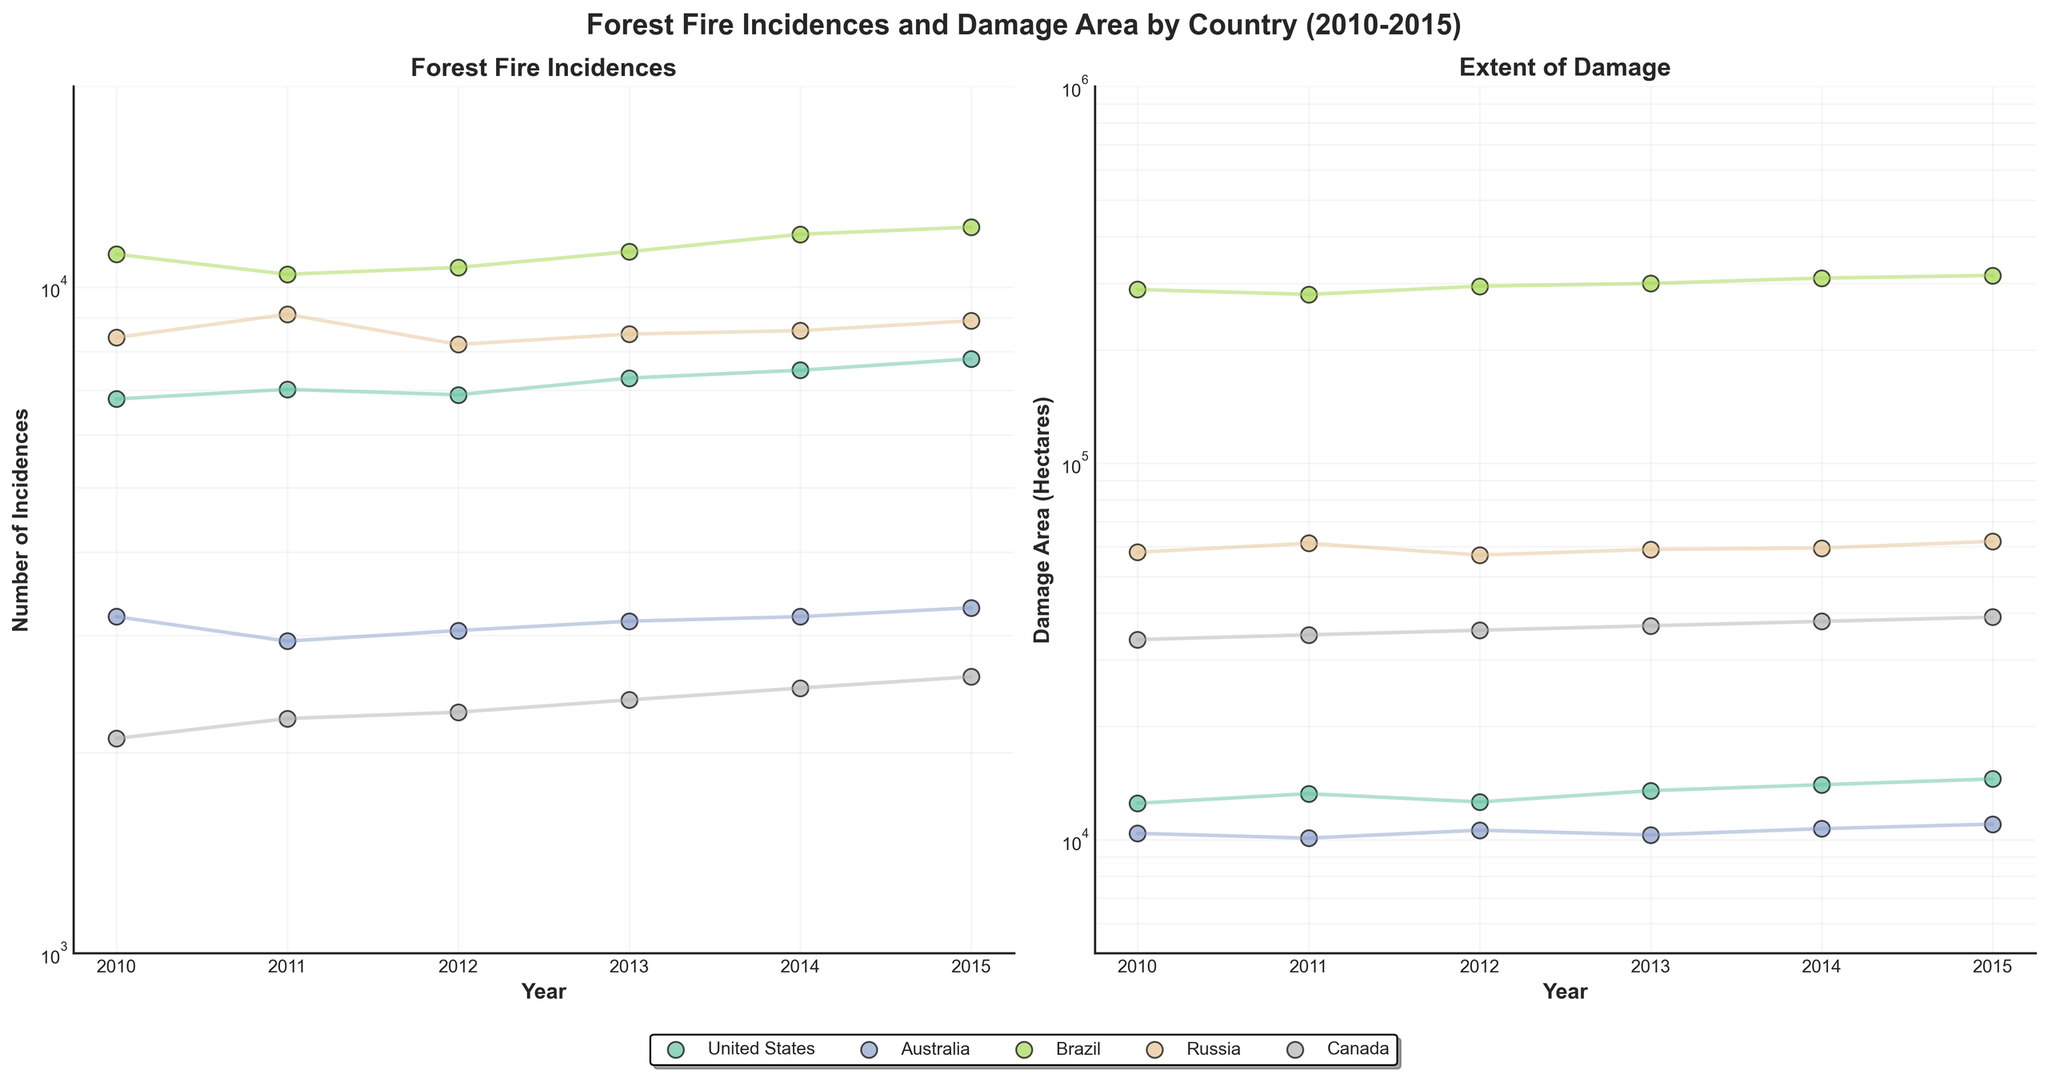What is the title of the figure? The title of the figure is located at the top of the plot and provides an overview of what the figure represents.
Answer: Forest Fire Incidences and Damage Area by Country (2010-2015) Which country had the highest number of forest fire incidences in 2015? To answer this, we need to look at the scatter plot on the left and identify the highest value for the year 2015. The point with the highest incidence value belongs to Brazil (Amazonas).
Answer: Brazil What is the range of the y-axis for the plot showing forest fire incidences? The range of the y-axis can be identified by looking at the values next to the ticks on the y-axis of the left subplot.
Answer: 1000 to 20000 Between which years did Brazil's damage area in hectares increase significantly? Check the trend line for Brazil in the right plot. Notice the big changes between years 2010–2011 and 2011–2012, but the most significant increase is between 2013 and 2014.
Answer: 2013 and 2014 Which country consistently shows the lowest damage area throughout the years? Look for the country that has the lowest plotted points in the right subplot. The points for Australia (Victoria) consistently appear near the bottom of the damage area plot from 2010 to 2015.
Answer: Australia Is there a correlation between the number of incidences and the extent of damage for countries over the years? Observe if the trends in the incidence plot and the damage area plot for each country follow a similar pattern. Regions like Brazil show that as the number of incidences increases, the damage area also increases, suggesting a positive correlation.
Answer: Yes, there appears to be a positive correlation For Russia, which year had the highest number of incidences and the highest damage area? Look at the peak points for Russia in both subplots. For the left plot, the highest incidence is around 2011, and for the right plot, the highest damage area is around 2015.
Answer: 2011 and 2015 Which years do both subplots use a log scale on the y-axis? By checking the y-axis labels of both subplots, it is evident that both use a log scale, shown by the logarithmic transition between the tick marks.
Answer: 2010-2015 How does Canada's forest fire damage area trend over the years depicted compare to California's? Observe the trend lines for Canada and the United States (California) on the right plot. While Canada's damage area decreases slightly over time or remains constant, California’s tends to increase, indicating California's damage area generally rises while Canada stays relatively stable or falls slightly.
Answer: California's increases, Canada's remains constant or decreases 